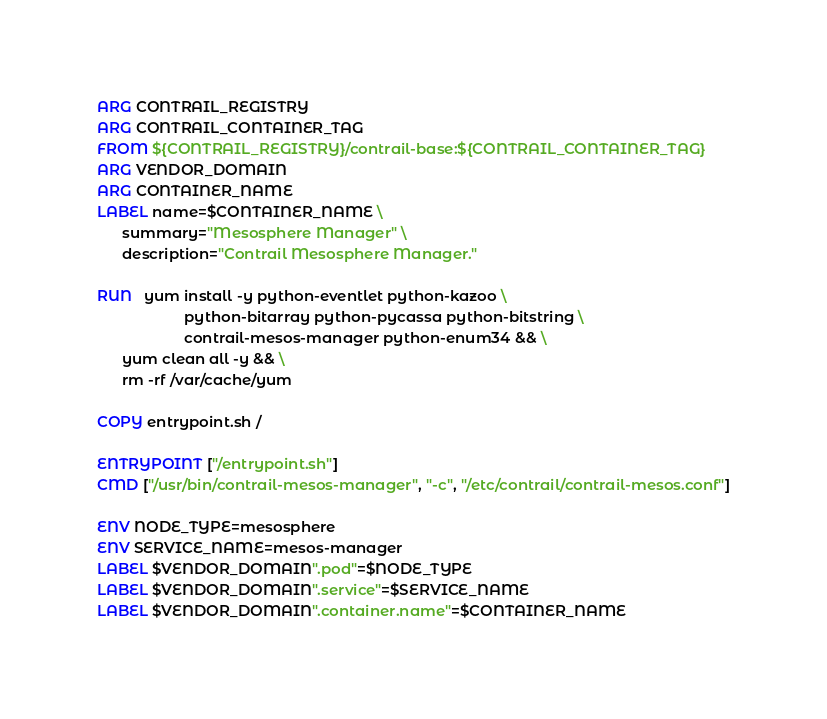Convert code to text. <code><loc_0><loc_0><loc_500><loc_500><_Dockerfile_>ARG CONTRAIL_REGISTRY
ARG CONTRAIL_CONTAINER_TAG
FROM ${CONTRAIL_REGISTRY}/contrail-base:${CONTRAIL_CONTAINER_TAG}
ARG VENDOR_DOMAIN
ARG CONTAINER_NAME
LABEL name=$CONTAINER_NAME \
      summary="Mesosphere Manager" \
      description="Contrail Mesosphere Manager."

RUN   yum install -y python-eventlet python-kazoo \
                     python-bitarray python-pycassa python-bitstring \
                     contrail-mesos-manager python-enum34 && \
      yum clean all -y && \
      rm -rf /var/cache/yum

COPY entrypoint.sh /

ENTRYPOINT ["/entrypoint.sh"]
CMD ["/usr/bin/contrail-mesos-manager", "-c", "/etc/contrail/contrail-mesos.conf"]

ENV NODE_TYPE=mesosphere
ENV SERVICE_NAME=mesos-manager
LABEL $VENDOR_DOMAIN".pod"=$NODE_TYPE
LABEL $VENDOR_DOMAIN".service"=$SERVICE_NAME
LABEL $VENDOR_DOMAIN".container.name"=$CONTAINER_NAME
</code> 